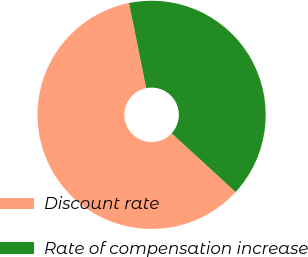<chart> <loc_0><loc_0><loc_500><loc_500><pie_chart><fcel>Discount rate<fcel>Rate of compensation increase<nl><fcel>60.0%<fcel>40.0%<nl></chart> 